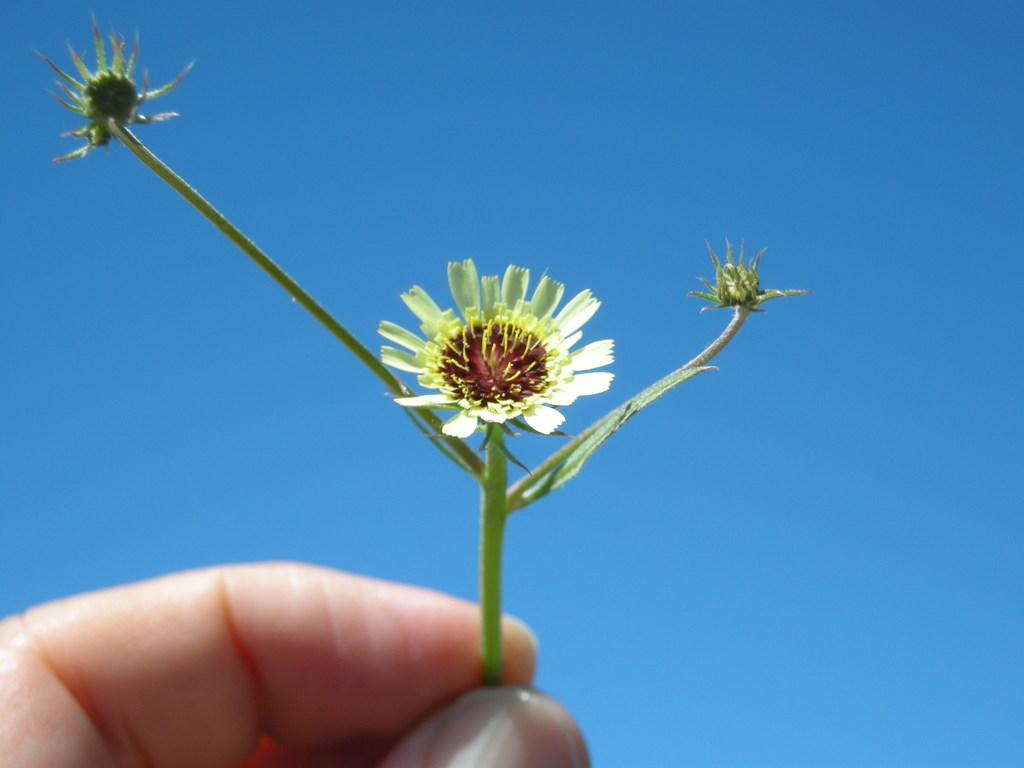What part of the body is visible in the image? There is a person's hand in the image. What is the hand holding? The hand is holding a stem. What can be found on the stem? There are flowers on the stem. What color is the background of the image? The background of the image is blue. What type of question is being asked in the image? There is no question present in the image; it features a person's hand holding a stem with flowers against a blue background. 